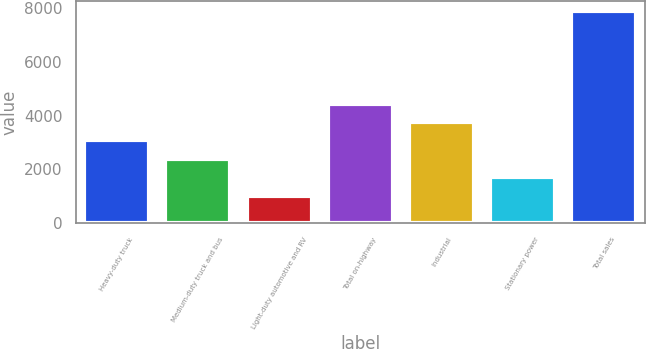Convert chart to OTSL. <chart><loc_0><loc_0><loc_500><loc_500><bar_chart><fcel>Heavy-duty truck<fcel>Medium-duty truck and bus<fcel>Light-duty automotive and RV<fcel>Total on-highway<fcel>Industrial<fcel>Stationary power<fcel>Total sales<nl><fcel>3081.8<fcel>2395.2<fcel>1022<fcel>4455<fcel>3768.4<fcel>1708.6<fcel>7888<nl></chart> 